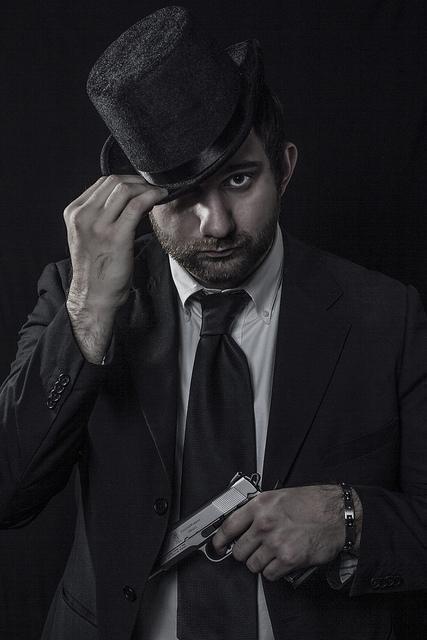How many ties are shown?
Give a very brief answer. 1. 